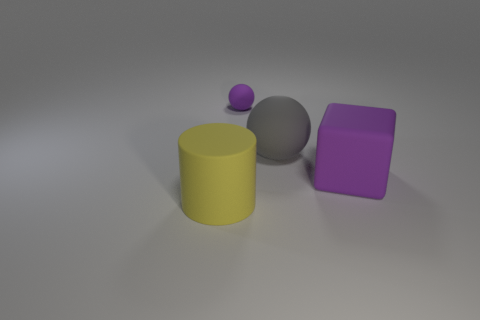There is a rubber ball behind the large gray matte sphere; does it have the same color as the big block?
Provide a succinct answer. Yes. Is there anything else that is the same color as the tiny ball?
Make the answer very short. Yes. The object that is the same color as the block is what shape?
Provide a short and direct response. Sphere. What is the color of the big block?
Make the answer very short. Purple. What color is the matte cube that is the same size as the gray ball?
Give a very brief answer. Purple. How many purple matte things are both in front of the big gray rubber sphere and behind the big gray rubber sphere?
Offer a very short reply. 0. Is there a big block made of the same material as the large gray object?
Your response must be concise. Yes. There is a matte cube that is the same color as the tiny rubber object; what is its size?
Your answer should be compact. Large. How many cylinders are small matte things or gray matte things?
Provide a short and direct response. 0. The cylinder is what size?
Offer a terse response. Large. 